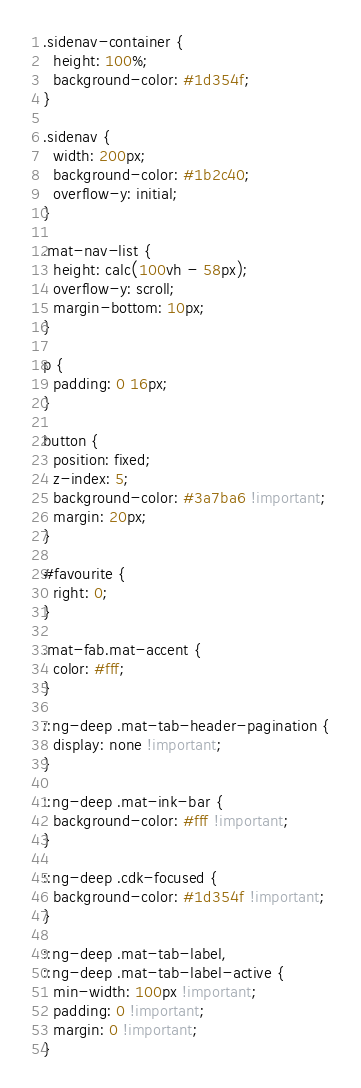Convert code to text. <code><loc_0><loc_0><loc_500><loc_500><_CSS_>.sidenav-container {
  height: 100%;
  background-color: #1d354f;
}

.sidenav {
  width: 200px;
  background-color: #1b2c40;
  overflow-y: initial;
}

.mat-nav-list {
  height: calc(100vh - 58px);
  overflow-y: scroll;
  margin-bottom: 10px;
}

p {
  padding: 0 16px;
}

button {
  position: fixed;
  z-index: 5;
  background-color: #3a7ba6 !important;
  margin: 20px;
}

#favourite {
  right: 0;
}

.mat-fab.mat-accent {
  color: #fff;
}

::ng-deep .mat-tab-header-pagination {
  display: none !important;
}

::ng-deep .mat-ink-bar {
  background-color: #fff !important;
}

::ng-deep .cdk-focused {
  background-color: #1d354f !important;
}

::ng-deep .mat-tab-label,
::ng-deep .mat-tab-label-active {
  min-width: 100px !important;
  padding: 0 !important;
  margin: 0 !important;
}
</code> 